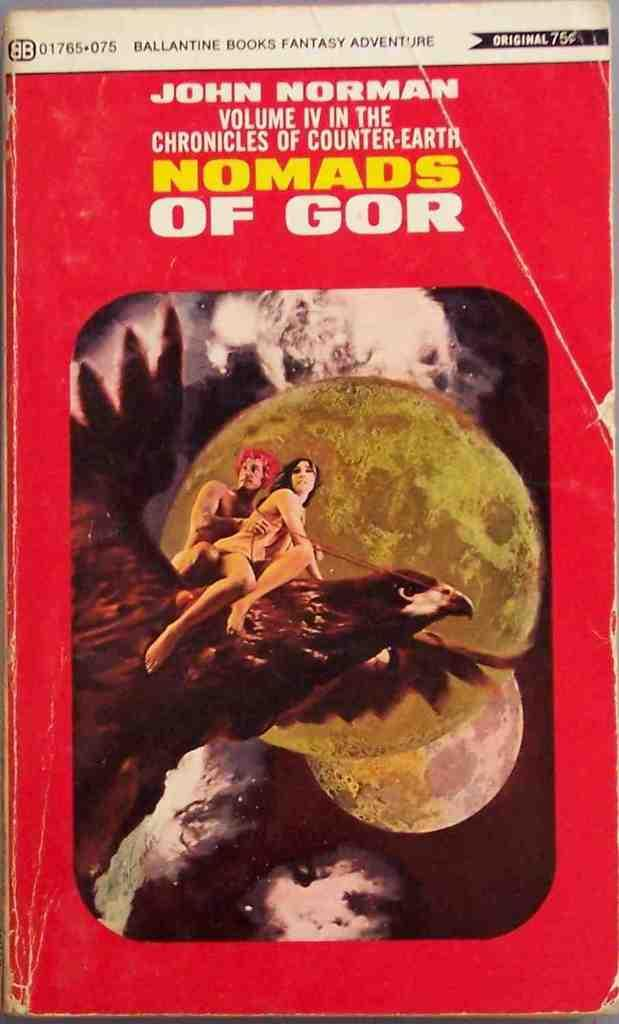Provide a one-sentence caption for the provided image. The book Nomads of Gor has two people riding a bird on the cover. 